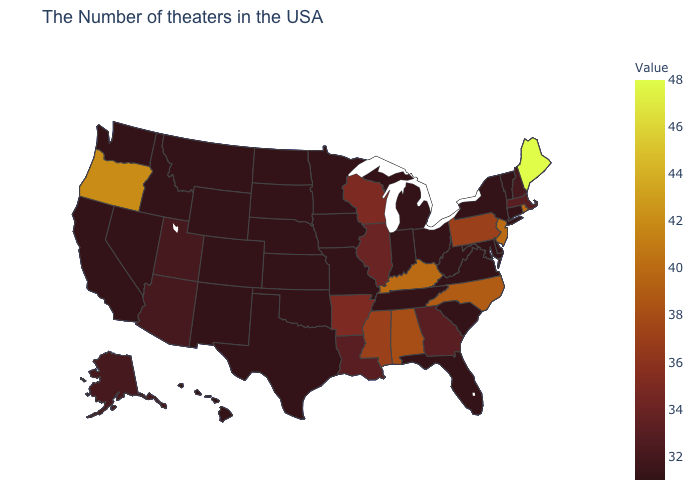Among the states that border Mississippi , which have the highest value?
Short answer required. Alabama. Among the states that border Utah , which have the lowest value?
Be succinct. Wyoming, Colorado, New Mexico, Idaho, Nevada. Which states hav the highest value in the MidWest?
Quick response, please. Wisconsin. Is the legend a continuous bar?
Be succinct. Yes. Does Rhode Island have the highest value in the USA?
Give a very brief answer. No. Which states hav the highest value in the South?
Write a very short answer. Kentucky. 